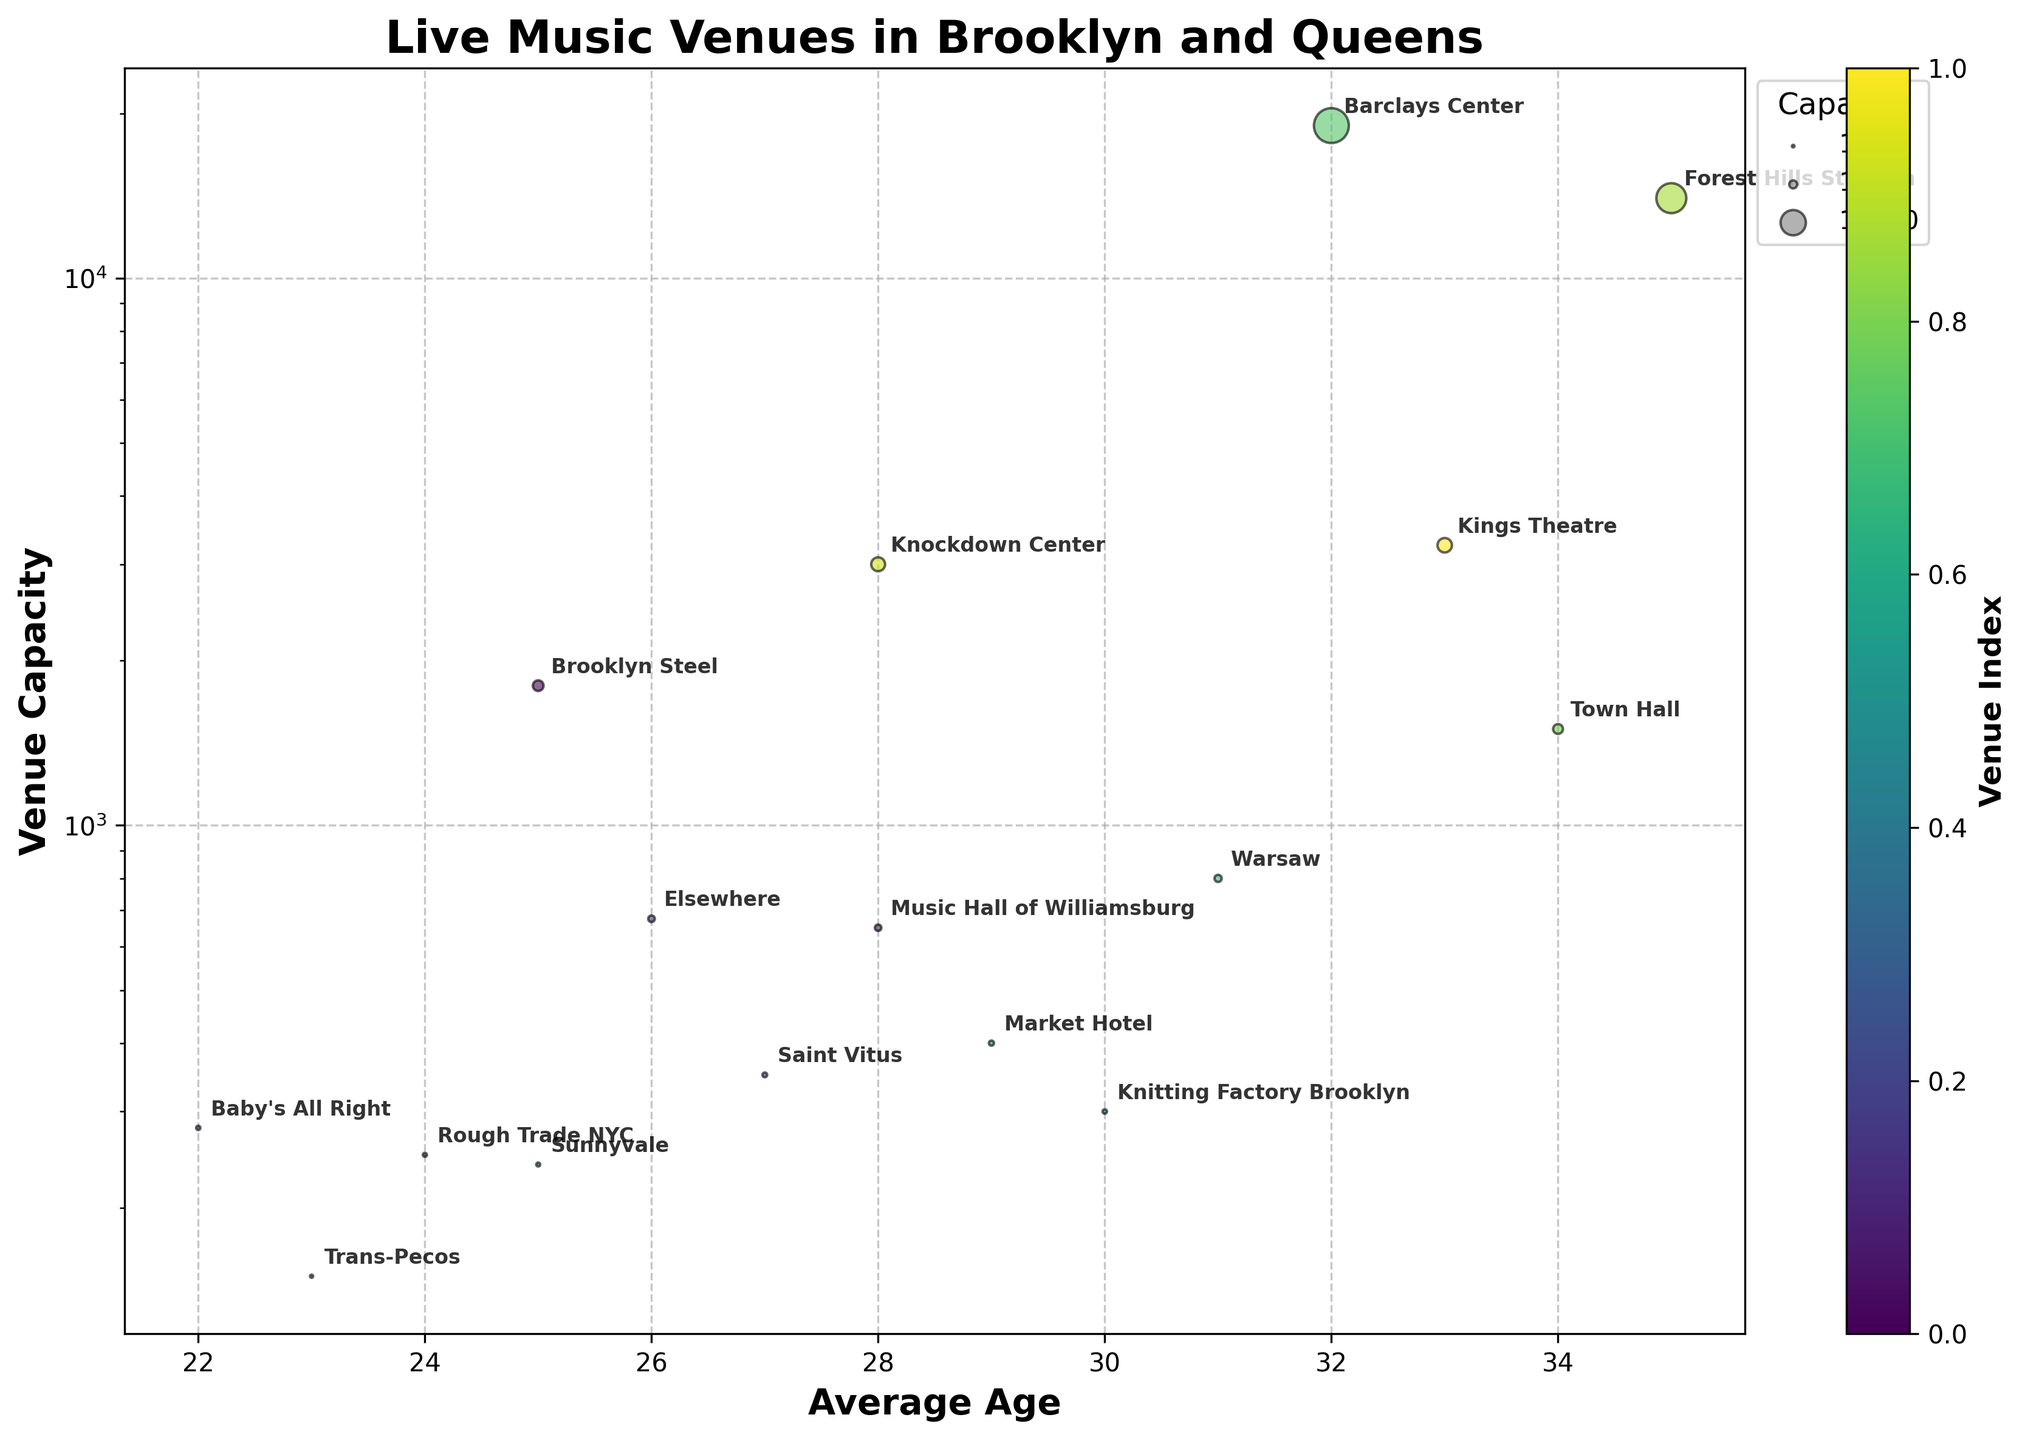Is the capacity of 'Brooklyn Steel' greater than the median capacity of all venues? First, identify the capacity of 'Brooklyn Steel', which is 1800. Then, list the capacities of all venues: [1800, 650, 250, 675, 350, 280, 300, 240, 400, 150, 800, 19000, 1500, 14000, 3000, 3250]. To find the median capacity, sort them in ascending order and find the middle value (or the average of the two middle values if the number of data points is even). The median is 725. Since 1800 is greater than 725, 'Brooklyn Steel' has a capacity greater than the median.
Answer: Yes What is the title of the chart? The title of the chart is displayed at the top of the figure in bold text.
Answer: Live Music Venues in Brooklyn and Queens Which venue has the highest average audience age? Look at the x-axis (Average Age) and find the venue that is farthest to the right. This is 'Forest Hills Stadium' with an average age of 35.
Answer: Forest Hills Stadium What are the two venues with the smallest capacities? Find the smallest capacity values on the y-axis. The two smallest capacity values are 150 and 240, which correspond to 'Trans-Pecos' and 'Sunnyvale', respectively.
Answer: Trans-Pecos and Sunnyvale Which venue has the smallest capacity among those with an average audience age of 25? Identify venues with an average age of 25 on the x-axis: 'Brooklyn Steel' and 'Sunnyvale'. Then, compare their capacities (y-axis): 1800 for 'Brooklyn Steel' and 240 for 'Sunnyvale'. 'Sunnyvale' has the smallest capacity.
Answer: Sunnyvale What is the difference in capacity between 'Barclays Center' and 'Knockdown Center'? Identify the capacities of 'Barclays Center' (19000) and 'Knockdown Center' (3000) from the y-axis. Subtract the smaller capacity from the larger capacity: 19000 - 3000 = 16000.
Answer: 16000 How many venues have an average audience age of 28 or 29? On the x-axis, locate venues with average ages of 28 and 29. These include 'Music Hall of Williamsburg' (28), 'Market Hotel' (29), and 'Knockdown Center' (28). Count them, which totals 3.
Answer: 3 Which venue has the largest capacity among those with an average audience age below 30? Identify venues with average age below 30 on the x-axis, then find the one with the largest capacity on the y-axis. 'Barclays Center' (19000) has the largest capacity among these venues.
Answer: Barclays Center Is the average audience age for 'Knitting Factory Brooklyn' higher or lower than 'Saint Vitus'? Compare the average ages from the x-axis: 'Knitting Factory Brooklyn' (30) and 'Saint Vitus' (27). 30 is greater than 27, so the average age for 'Knitting Factory Brooklyn' is higher than 'Saint Vitus'.
Answer: Higher 